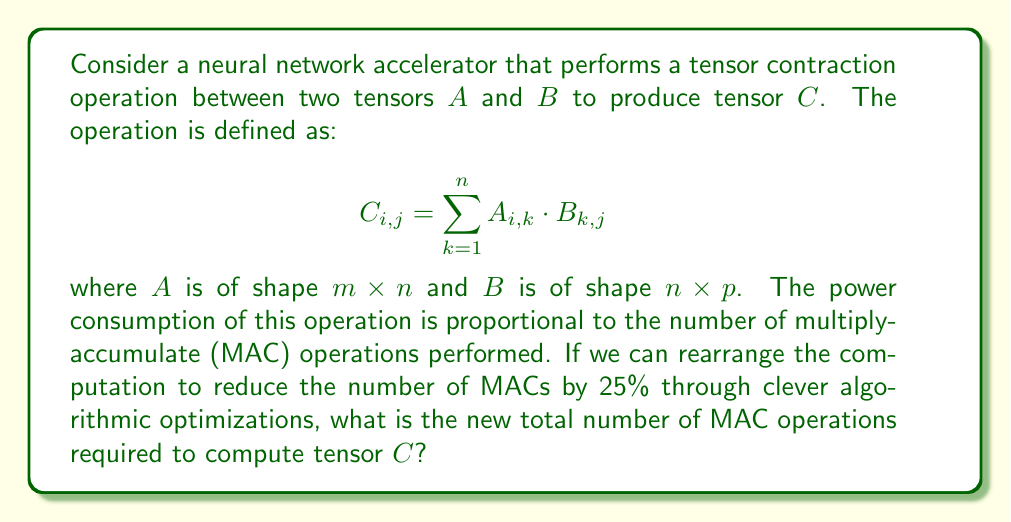Teach me how to tackle this problem. To solve this problem, we'll follow these steps:

1. Calculate the original number of MAC operations:
   - The shape of the resulting tensor $C$ will be $m \times p$.
   - For each element in $C$, we perform $n$ multiply-accumulate operations.
   - Total original MAC operations = $m \times p \times n$

2. Apply the 25% reduction:
   - New number of MAC operations = Original MAC operations × (1 - 0.25)
   - New number of MAC operations = $m \times p \times n \times 0.75$

3. Simplify the expression:
   - New number of MAC operations = $0.75mnp$

This formula gives us the optimized number of MAC operations after the 25% reduction in power consumption. As a senior engineer focused on energy-efficient hardware design, this optimization could significantly reduce the power requirements of the neural network accelerator, potentially leading to improved battery life in mobile devices or reduced cooling needs in data centers.
Answer: $0.75mnp$ MAC operations 